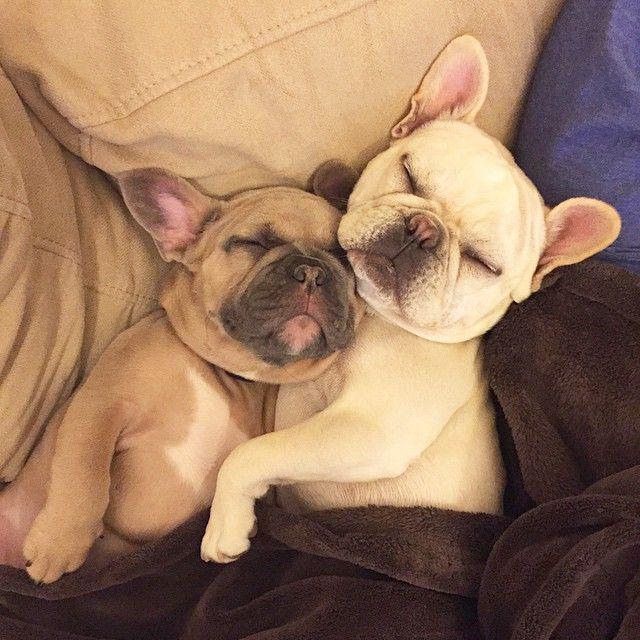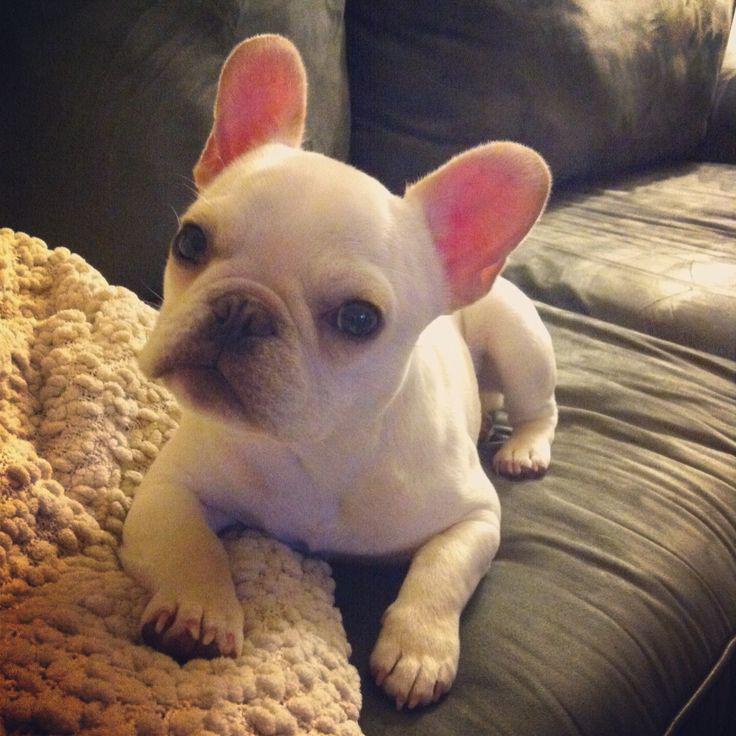The first image is the image on the left, the second image is the image on the right. For the images displayed, is the sentence "A young person is lying with at least one dog." factually correct? Answer yes or no. No. The first image is the image on the left, the second image is the image on the right. Given the left and right images, does the statement "An image shows a human child resting with at least one snoozing dog." hold true? Answer yes or no. No. 